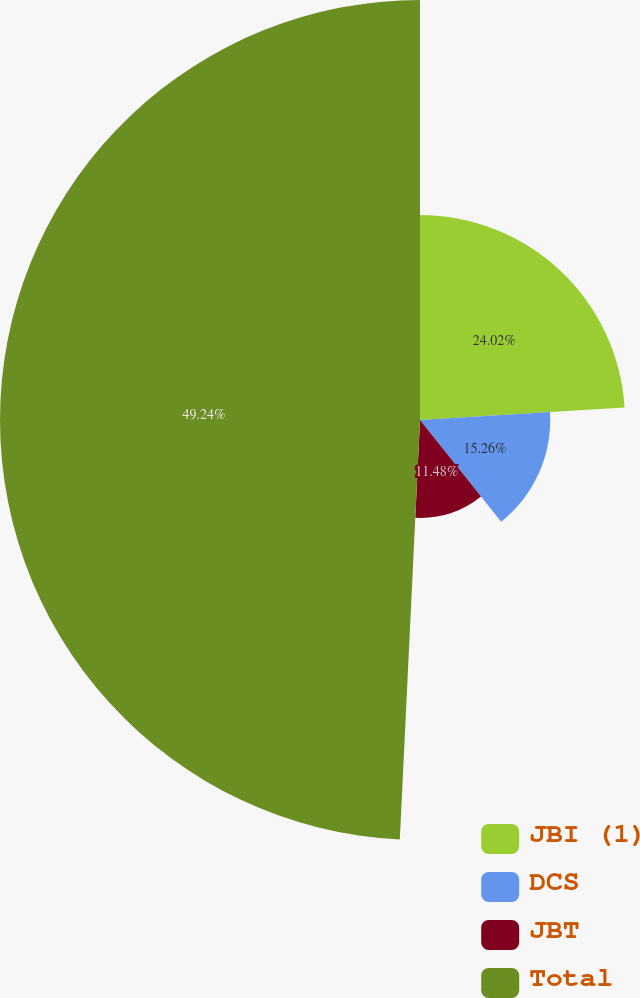Convert chart to OTSL. <chart><loc_0><loc_0><loc_500><loc_500><pie_chart><fcel>JBI (1)<fcel>DCS<fcel>JBT<fcel>Total<nl><fcel>24.02%<fcel>15.26%<fcel>11.48%<fcel>49.23%<nl></chart> 